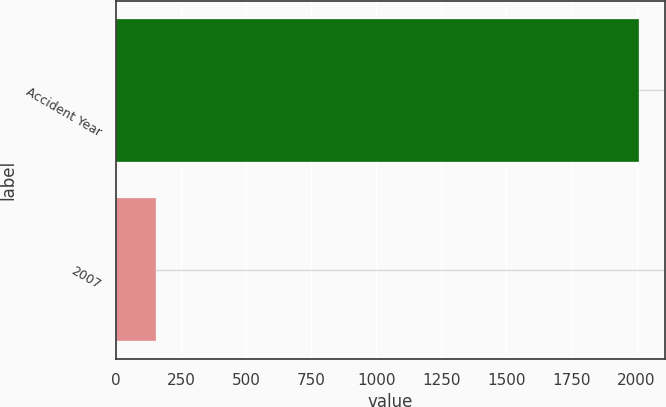Convert chart to OTSL. <chart><loc_0><loc_0><loc_500><loc_500><bar_chart><fcel>Accident Year<fcel>2007<nl><fcel>2008<fcel>153<nl></chart> 